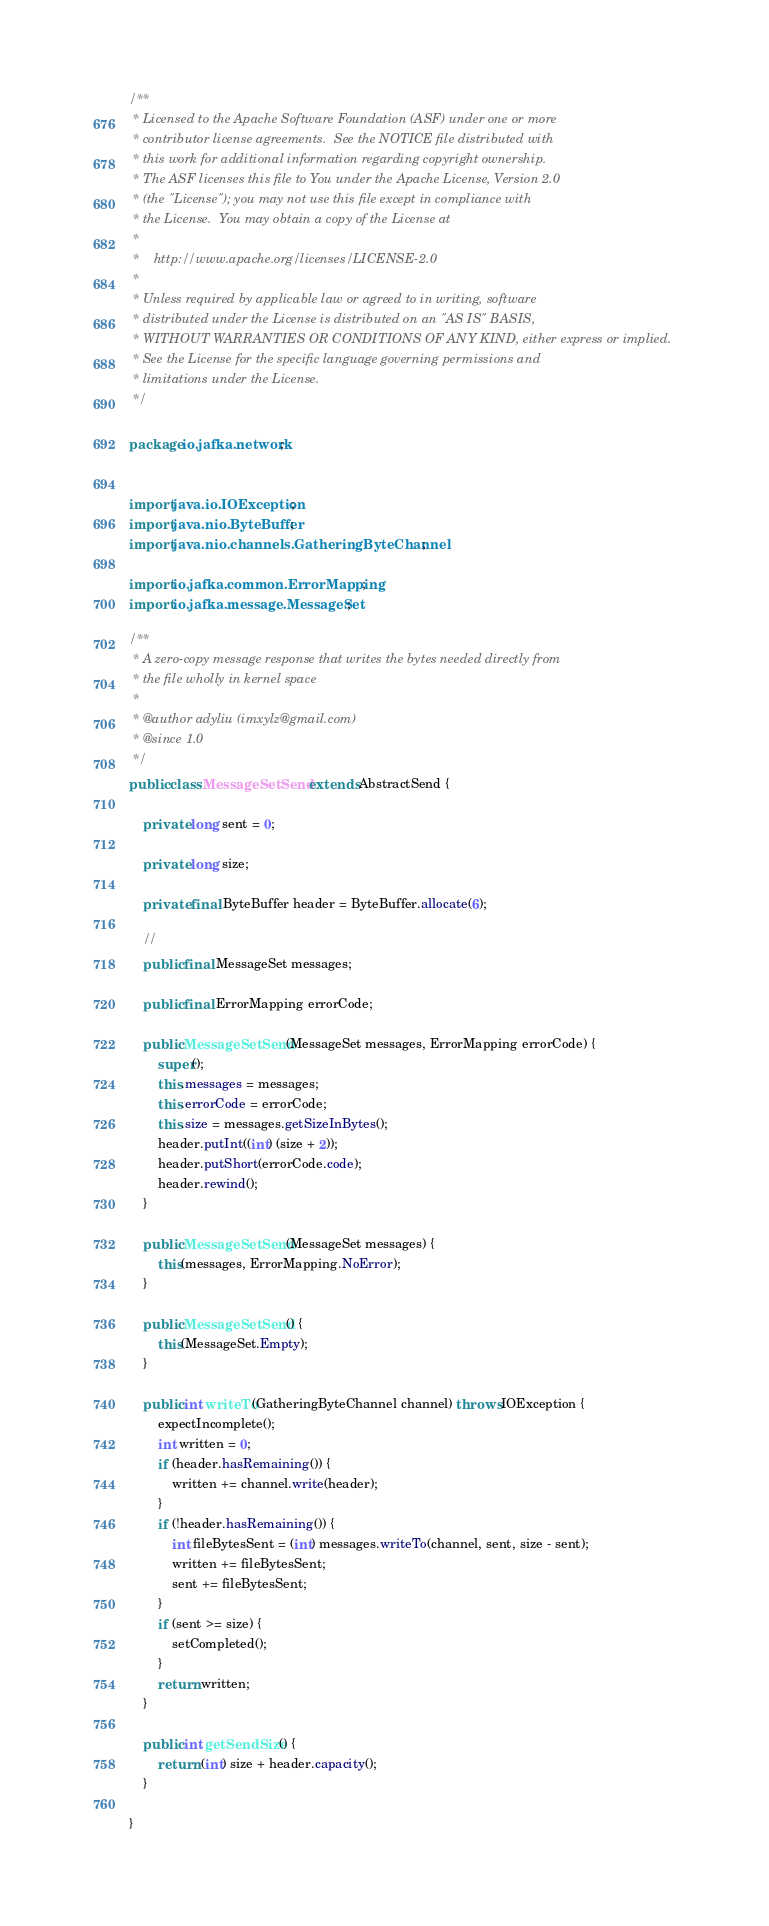Convert code to text. <code><loc_0><loc_0><loc_500><loc_500><_Java_>/**
 * Licensed to the Apache Software Foundation (ASF) under one or more
 * contributor license agreements.  See the NOTICE file distributed with
 * this work for additional information regarding copyright ownership.
 * The ASF licenses this file to You under the Apache License, Version 2.0
 * (the "License"); you may not use this file except in compliance with
 * the License.  You may obtain a copy of the License at
 * 
 *    http://www.apache.org/licenses/LICENSE-2.0
 *
 * Unless required by applicable law or agreed to in writing, software
 * distributed under the License is distributed on an "AS IS" BASIS,
 * WITHOUT WARRANTIES OR CONDITIONS OF ANY KIND, either express or implied.
 * See the License for the specific language governing permissions and
 * limitations under the License.
 */

package io.jafka.network;


import java.io.IOException;
import java.nio.ByteBuffer;
import java.nio.channels.GatheringByteChannel;

import io.jafka.common.ErrorMapping;
import io.jafka.message.MessageSet;

/**
 * A zero-copy message response that writes the bytes needed directly from
 * the file wholly in kernel space
 * 
 * @author adyliu (imxylz@gmail.com)
 * @since 1.0
 */
public class MessageSetSend extends AbstractSend {

    private long sent = 0;

    private long size;

    private final ByteBuffer header = ByteBuffer.allocate(6);

    //
    public final MessageSet messages;

    public final ErrorMapping errorCode;

    public MessageSetSend(MessageSet messages, ErrorMapping errorCode) {
        super();
        this.messages = messages;
        this.errorCode = errorCode;
        this.size = messages.getSizeInBytes();
        header.putInt((int) (size + 2));
        header.putShort(errorCode.code);
        header.rewind();
    }

    public MessageSetSend(MessageSet messages) {
        this(messages, ErrorMapping.NoError);
    }

    public MessageSetSend() {
        this(MessageSet.Empty);
    }

    public int writeTo(GatheringByteChannel channel) throws IOException {
        expectIncomplete();
        int written = 0;
        if (header.hasRemaining()) {
            written += channel.write(header);
        }
        if (!header.hasRemaining()) {
            int fileBytesSent = (int) messages.writeTo(channel, sent, size - sent);
            written += fileBytesSent;
            sent += fileBytesSent;
        }
        if (sent >= size) {
            setCompleted();
        }
        return written;
    }

    public int getSendSize() {
        return (int) size + header.capacity();
    }

}
</code> 